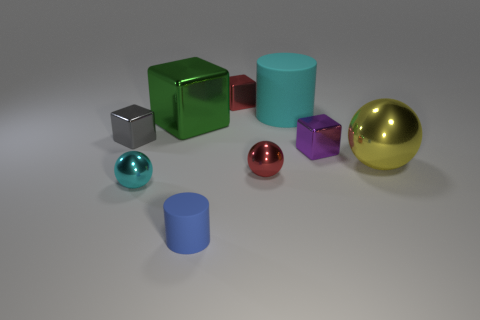How many large yellow metal things are the same shape as the cyan shiny thing?
Your response must be concise. 1. What color is the large shiny thing that is left of the large object in front of the big metallic cube?
Provide a short and direct response. Green. Is the number of cyan metal balls that are on the left side of the tiny cyan object the same as the number of blue cylinders?
Offer a terse response. No. Are there any cyan shiny things that have the same size as the purple metallic cube?
Give a very brief answer. Yes. There is a blue matte object; is it the same size as the cylinder that is behind the big sphere?
Your answer should be compact. No. Is the number of large cubes right of the small cyan sphere the same as the number of tiny red cubes on the left side of the small blue cylinder?
Ensure brevity in your answer.  No. There is a big thing in front of the green metal cube; what material is it?
Keep it short and to the point. Metal. Do the green object and the gray metal cube have the same size?
Keep it short and to the point. No. Is the number of metallic objects that are in front of the tiny gray object greater than the number of red balls?
Your response must be concise. Yes. What size is the blue object that is made of the same material as the cyan cylinder?
Make the answer very short. Small. 